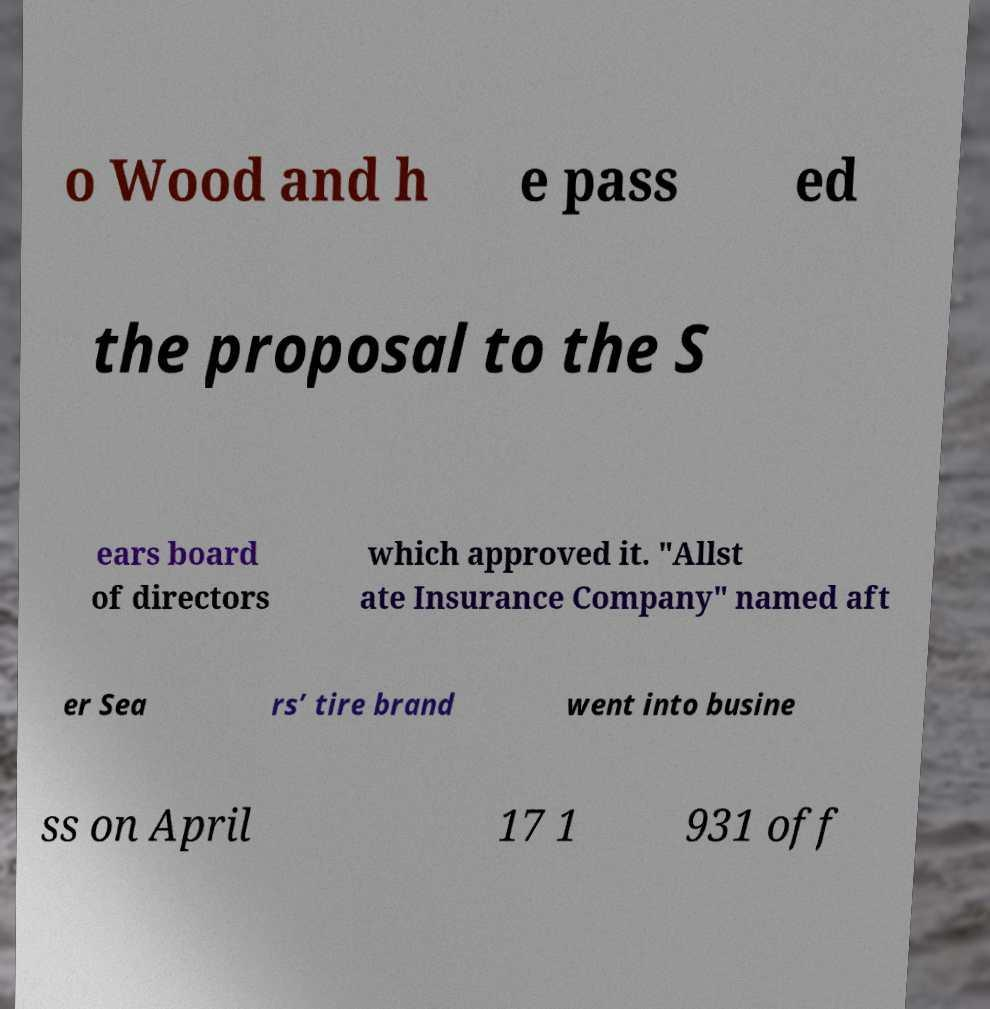I need the written content from this picture converted into text. Can you do that? o Wood and h e pass ed the proposal to the S ears board of directors which approved it. "Allst ate Insurance Company" named aft er Sea rs’ tire brand went into busine ss on April 17 1 931 off 